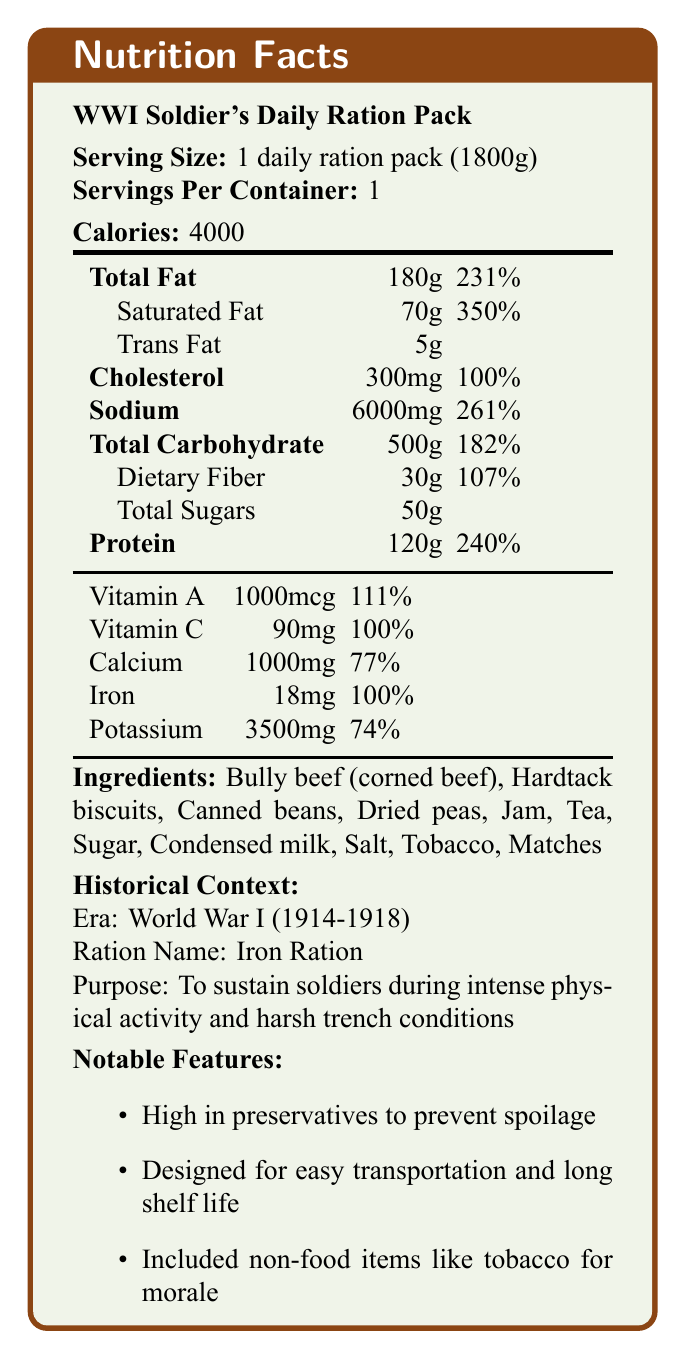what is the serving size of the daily ration pack? The document states that the serving size for the daily ration pack is 1 pack, weighing 1800 grams.
Answer: 1 daily ration pack (1800g) how many calories are provided in one daily ration pack? The document indicates that the calories per serving for one daily ration pack amount to 4000 calories.
Answer: 4000 calories what is the daily value percentage of Total Fat in the ration pack? The document lists the daily value percentage of Total Fat as 231%.
Answer: 231% how much sodium is in the daily ration pack? The document specifies the amount of Sodium in the daily ration pack as 6000 milligrams.
Answer: 6000mg what is the purpose of the high caloric content in the WWI soldier's daily ration pack? The historical context section explains that the high caloric content is intended to sustain soldiers during intense physical activity and harsh trench conditions.
Answer: To sustain soldiers during intense physical activity and harsh trench conditions which of the following is not included in the ingredients list? A. Dried peas B. Tea C. Fresh fruits D. Canned beans Fresh fruits are not listed among the ingredients, while Dried peas, Tea, and Canned beans are included.
Answer: C what is the daily value percentage of Dietary Fiber in the ration pack? The document shows the daily value percentage for Dietary Fiber as 107%.
Answer: 107% how much protein does the daily ration pack provide? The document lists the amount of Protein in the daily ration pack as 120 grams.
Answer: 120g is the ration pack designed for easy transportation and long shelf life? According to the document's historical context, the ration pack is designed for easy transportation and long shelf life.
Answer: Yes which vitamin in the ration pack meets 100% of the daily value? A. Vitamin A B. Vitamin C C. Calcium D. Potassium The document shows that Vitamin C meets 100% of the daily value, while other nutrients have different percentages.
Answer: B does the nutritional information include the daily value for Trans Fat? The document does not provide the daily value percentage for Trans Fat.
Answer: No what items were commonly included in Wwi rations that are not food? The historical context section notes that non-food items like tobacco and matches were included in the rations for morale purposes.
Answer: Tobacco and matches what key features characterized the WWI soldier's ration pack? The document summarizes the key features of the ration pack in the historical context section.
Answer: High in preservatives, designed for easy transportation and long shelf life, included non-food items like tobacco for morale can we determine the exact content of fresh fruits in the ration pack? The document does not mention fresh fruits in the ingredients list, hence we cannot determine their exact content.
Answer: Not enough information summarize the main idea of the document. The document offers a comprehensive overview of the nutritional and historical aspects of the WWI soldier's daily ration pack. It highlights its high caloric and nutrient content, along with its practical design for sustaining soldiers in difficult conditions.
Answer: The document provides detailed nutritional information about the WWI soldier's daily ration pack, including serving size, caloric content, key nutrients, and historical context. The ration pack is designed for high caloric and nutritional content to sustain soldiers during intense physical activity and harsh trench conditions, with notable features such as being high in preservatives, easy to transport, and including morale-boosting non-food items. 